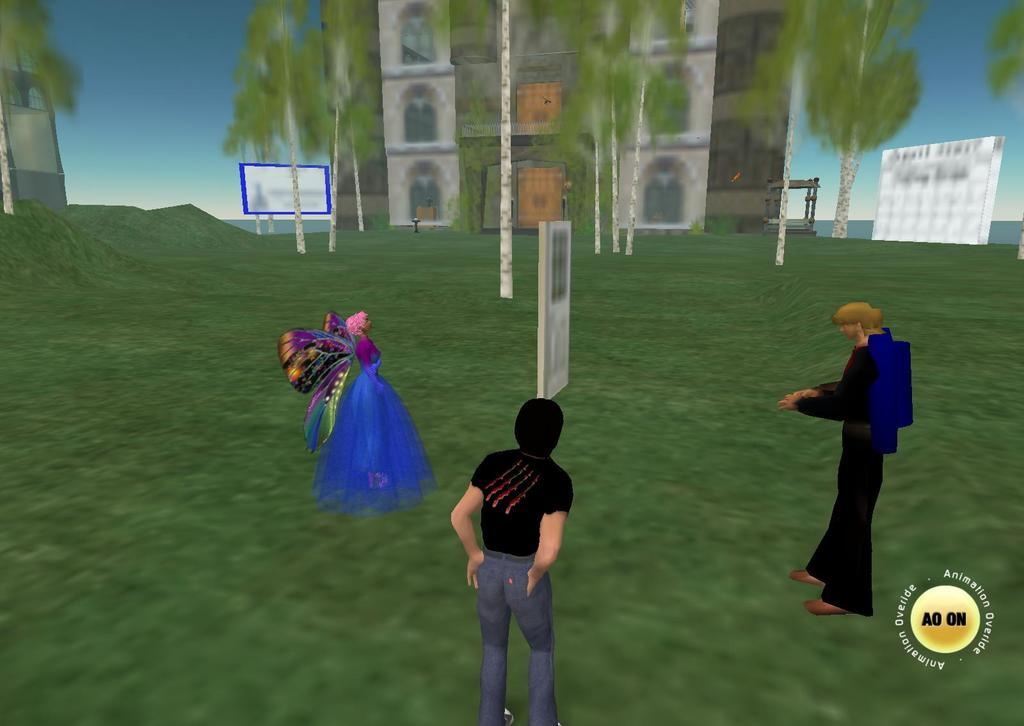What type of picture is in the image? The image contains an animated picture. How many characters are in the animated picture? There are two men and a woman in the animated picture. What are the characters wearing? The characters in the animated picture are wearing clothes. What type of natural environment is visible in the image? There is grass visible in the image. What type of structure is present in the image? There is a building in the image. What other natural elements can be seen in the image? Trees are present in the image. What else can be seen in the image? There are boards in the image. What is visible in the background of the image? The sky is visible in the image. What type of wilderness can be seen in the image? There is no wilderness present in the image; it contains an animated picture with a building, trees, and other elements. 